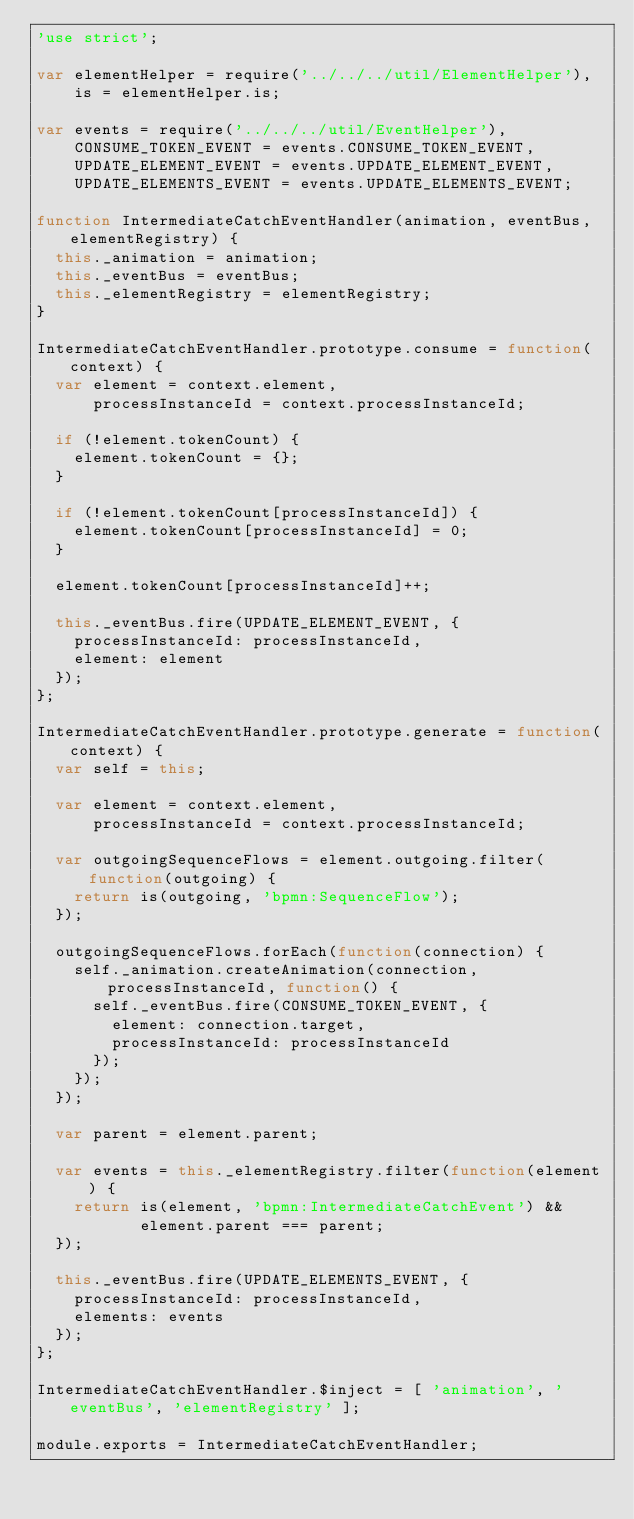Convert code to text. <code><loc_0><loc_0><loc_500><loc_500><_JavaScript_>'use strict';

var elementHelper = require('../../../util/ElementHelper'),
    is = elementHelper.is;

var events = require('../../../util/EventHelper'),
    CONSUME_TOKEN_EVENT = events.CONSUME_TOKEN_EVENT,
    UPDATE_ELEMENT_EVENT = events.UPDATE_ELEMENT_EVENT,
    UPDATE_ELEMENTS_EVENT = events.UPDATE_ELEMENTS_EVENT;

function IntermediateCatchEventHandler(animation, eventBus, elementRegistry) {
  this._animation = animation;
  this._eventBus = eventBus;
  this._elementRegistry = elementRegistry;
}

IntermediateCatchEventHandler.prototype.consume = function(context) {
  var element = context.element,
      processInstanceId = context.processInstanceId;

  if (!element.tokenCount) {
    element.tokenCount = {};
  }

  if (!element.tokenCount[processInstanceId]) {
    element.tokenCount[processInstanceId] = 0;
  }

  element.tokenCount[processInstanceId]++;

  this._eventBus.fire(UPDATE_ELEMENT_EVENT, {
    processInstanceId: processInstanceId,
    element: element
  });
};

IntermediateCatchEventHandler.prototype.generate = function(context) {
  var self = this;

  var element = context.element,
      processInstanceId = context.processInstanceId;

  var outgoingSequenceFlows = element.outgoing.filter(function(outgoing) {
    return is(outgoing, 'bpmn:SequenceFlow');
  });

  outgoingSequenceFlows.forEach(function(connection) {
    self._animation.createAnimation(connection, processInstanceId, function() {
      self._eventBus.fire(CONSUME_TOKEN_EVENT, {
        element: connection.target,
        processInstanceId: processInstanceId
      });
    });
  });

  var parent = element.parent;

  var events = this._elementRegistry.filter(function(element) {
    return is(element, 'bpmn:IntermediateCatchEvent') &&
           element.parent === parent;
  });

  this._eventBus.fire(UPDATE_ELEMENTS_EVENT, {
    processInstanceId: processInstanceId,
    elements: events
  });
};

IntermediateCatchEventHandler.$inject = [ 'animation', 'eventBus', 'elementRegistry' ];

module.exports = IntermediateCatchEventHandler;</code> 